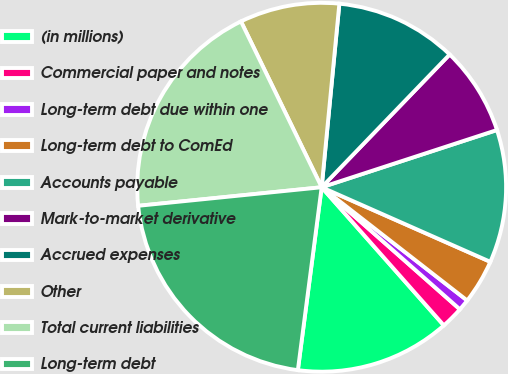Convert chart. <chart><loc_0><loc_0><loc_500><loc_500><pie_chart><fcel>(in millions)<fcel>Commercial paper and notes<fcel>Long-term debt due within one<fcel>Long-term debt to ComEd<fcel>Accounts payable<fcel>Mark-to-market derivative<fcel>Accrued expenses<fcel>Other<fcel>Total current liabilities<fcel>Long-term debt<nl><fcel>13.59%<fcel>1.96%<fcel>0.99%<fcel>3.9%<fcel>11.65%<fcel>7.77%<fcel>10.68%<fcel>8.74%<fcel>19.4%<fcel>21.34%<nl></chart> 